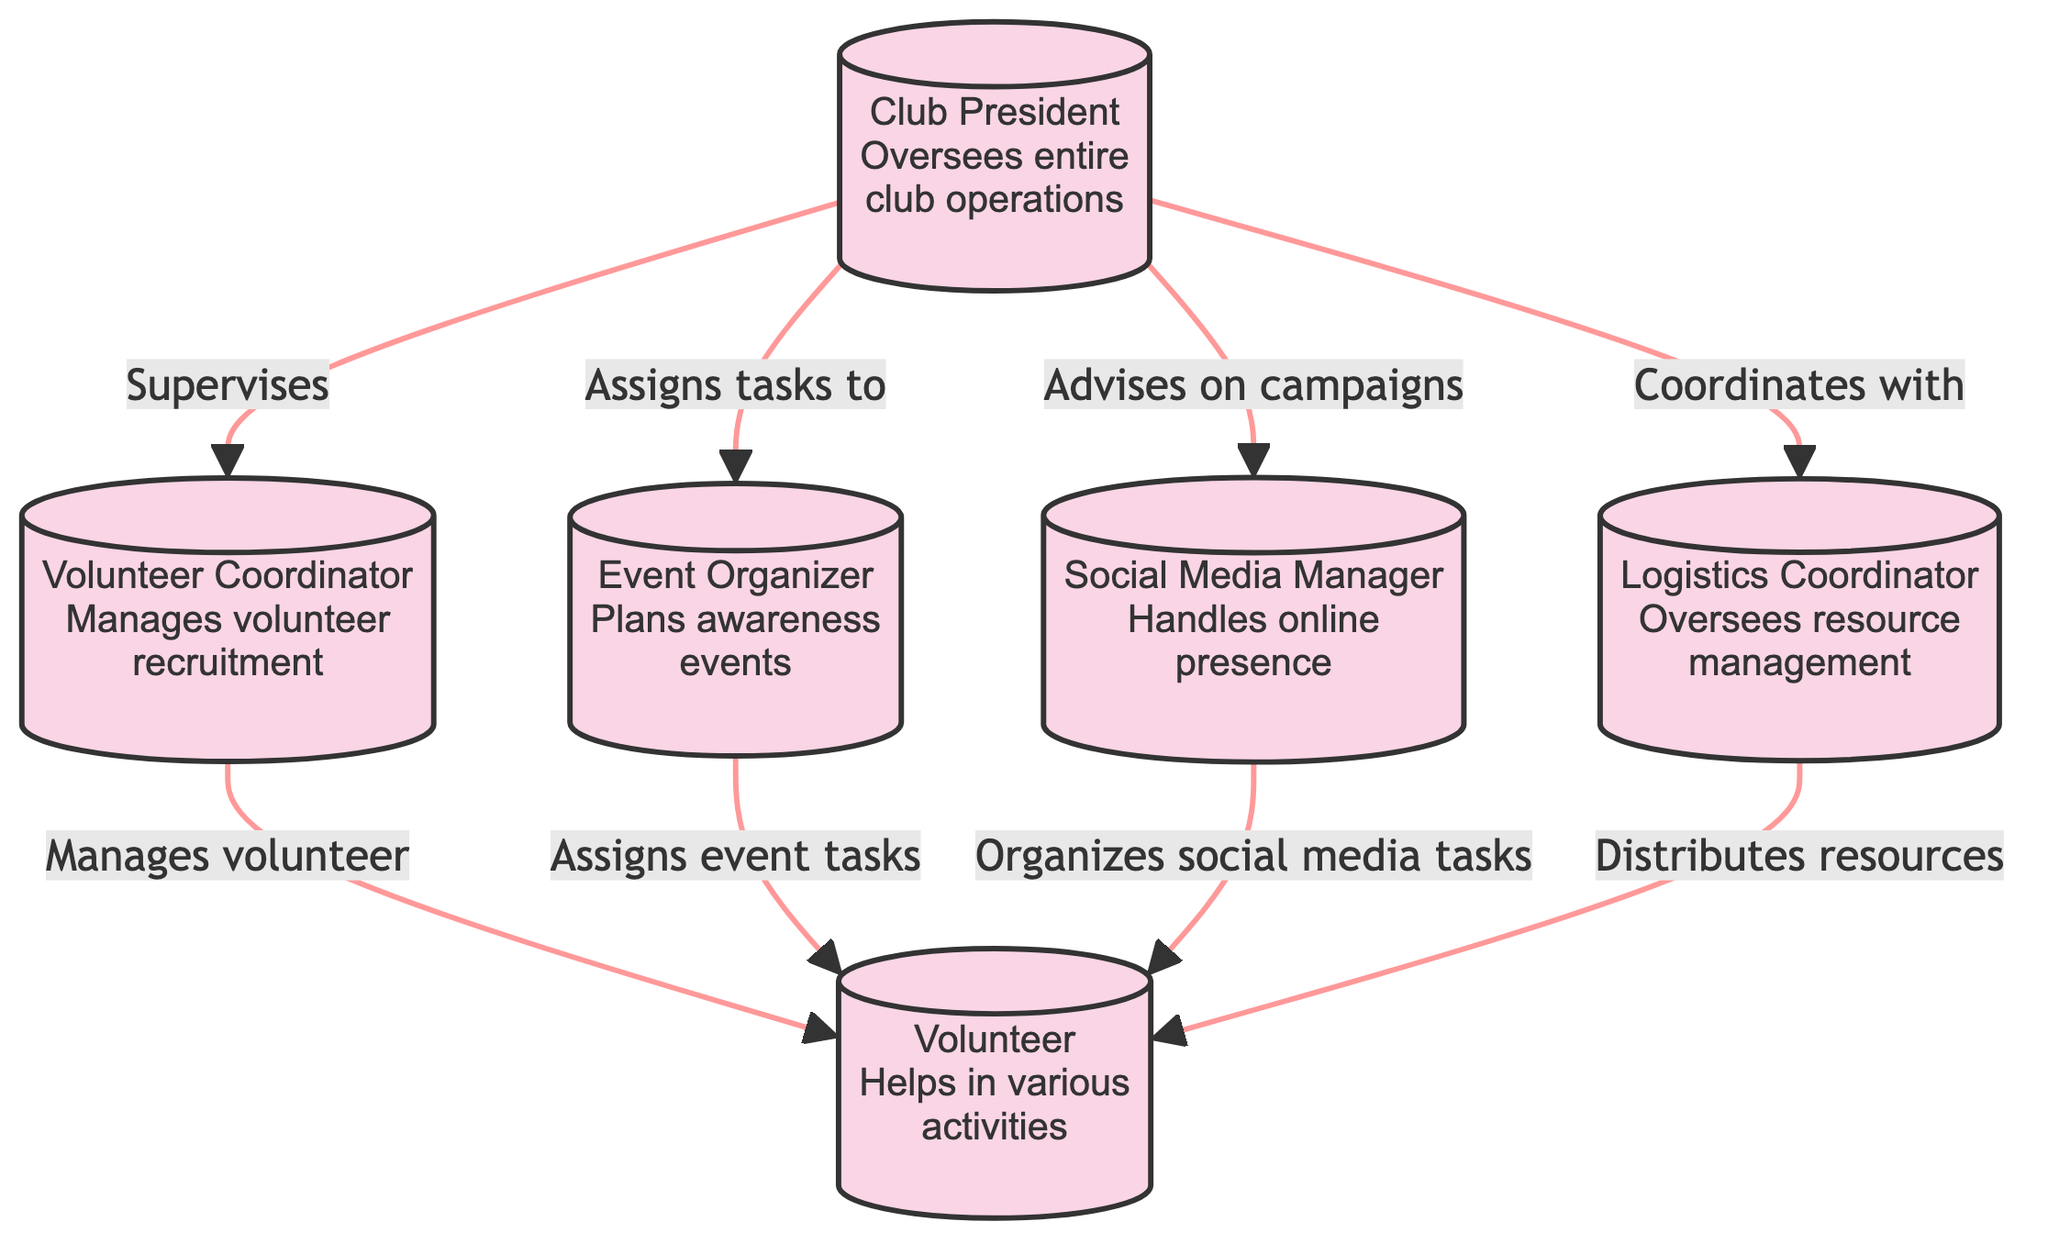What is the role of the Club President? The Club President's role is described as "Oversees entire club operations" in the diagram. Therefore, this is directly taken from the label of the node representing the Club President.
Answer: Oversees entire club operations How many nodes are in the diagram? The diagram has six individual entities or roles represented as nodes. Counting through the nodes (Club President, Volunteer Coordinator, Event Organizer, Social Media Manager, Logistics Coordinator, and Volunteer) gives a total of 6 nodes.
Answer: 6 Who does the Volunteer Coordinator manage? The edge from the Volunteer Coordinator to the Volunteer shows the relationship "Manages volunteer." Thus, it clarifies that the Volunteer Coordinator specifically manages the Volunteer role.
Answer: Volunteer What is the relationship between the Club President and the Event Organizer? The edge from the Club President to the Event Organizer indicates the relationship "Assigns tasks to," which informs us that the Club President assigns tasks to the Event Organizer.
Answer: Assigns tasks to Which role does the Social Media Manager organize tasks for? From the edge connecting the Social Media Manager to the Volunteer, the relationship stated is "Organizes social media tasks for." This reveals that the Social Media Manager organizes social media tasks specifically for the Volunteer.
Answer: Volunteer How many total edges are in the diagram? The diagram includes a total of seven edges that represent the various relationships among the roles. Counting each edge listed in the relationships shows there are 7 edges.
Answer: 7 Who coordinates with the Logistics Coordinator? The edge from the Club President to the Logistics Coordinator indicates a relationship of "Coordinates with." Therefore, the Club President coordinates with the Logistics Coordinator.
Answer: Club President What is the primary responsibility of the Event Organizer? According to the description given in the node for Event Organizer, the primary responsibility is to "Plans and manages awareness events." This is a direct transcription from the role label in the diagram.
Answer: Plans and manages awareness events 